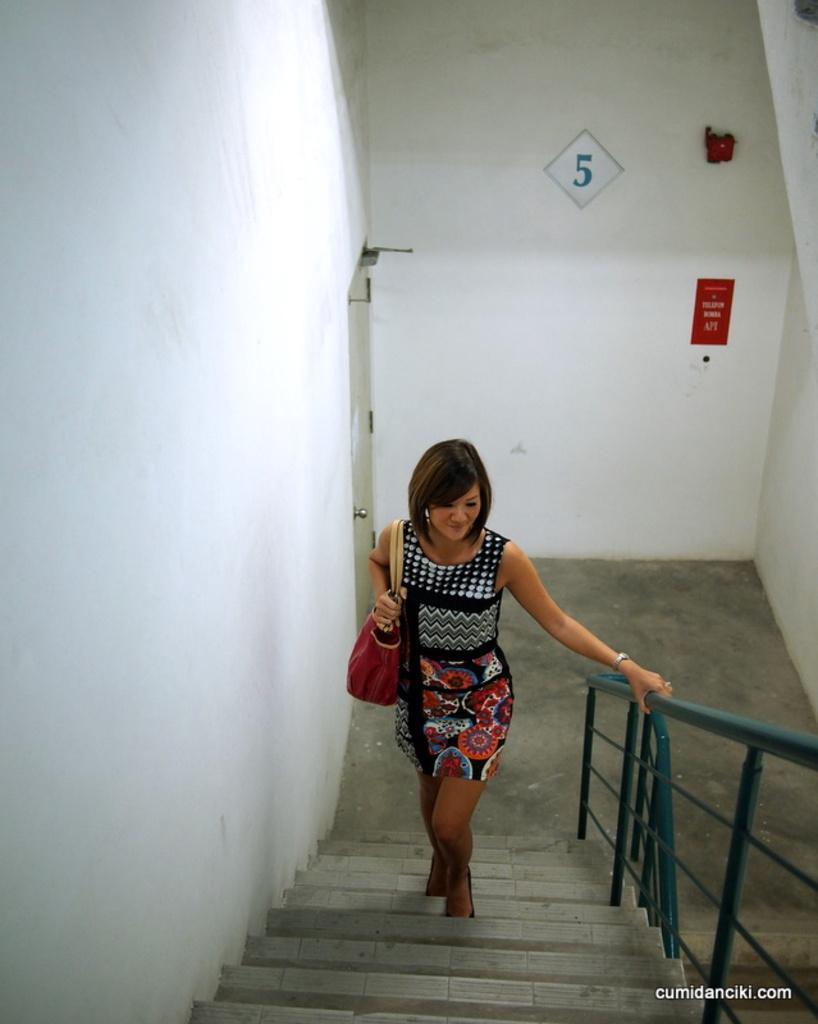How would you summarize this image in a sentence or two? This picture shows a woman climbing Stairs and she is holding a handbag and we see poster on the wall and a number and we see text at the bottom right corner of the picture. 